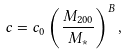<formula> <loc_0><loc_0><loc_500><loc_500>c = c _ { 0 } \left ( \frac { M _ { 2 0 0 } } { M _ { * } } \right ) ^ { B } ,</formula> 